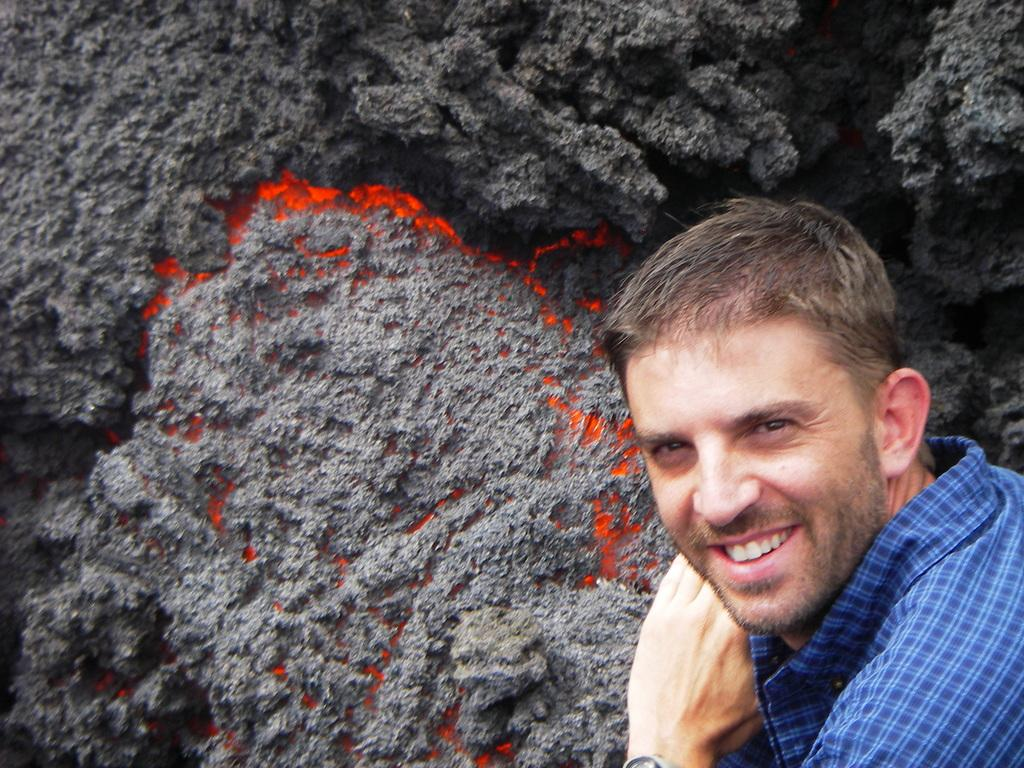Who is present in the image? There is a man in the image. What is the man doing in the image? The man is smiling in the image. What is the man wearing in the image? The man is wearing a blue shirt in the image. What natural phenomenon can be seen in the image? There is lava in the image. What colors are the lava in the image? The lava is in grey and red colors in the image. Where is the man's mom in the image? There is no mention of the man's mom in the image, so we cannot determine her location. 